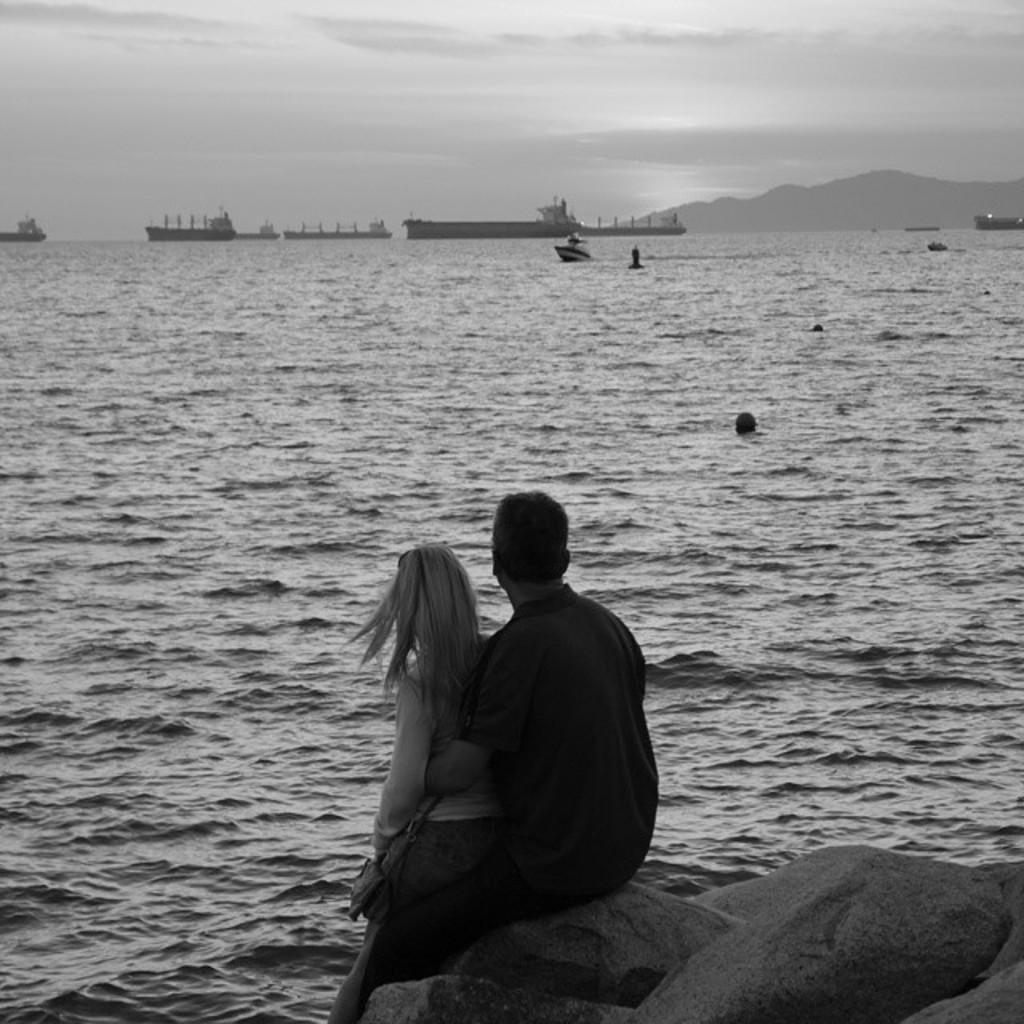Please provide a concise description of this image. This is a black and white image and here we can see people sitting on the rock and in the background, there are ships and boats on the water and we can see some people. At the top, there is sky. 